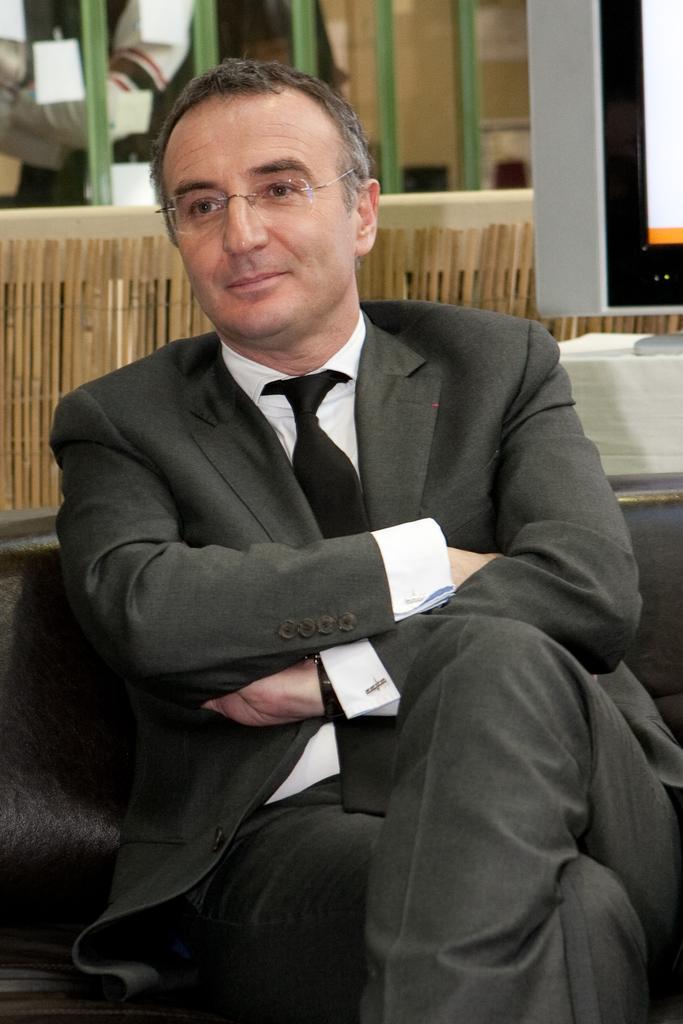Please provide a concise description of this image. In this picture I can see there is a man sitting, he is wearing a blazer, he has spectacles and he is smiling. There is a television in the backdrop and there is a wooden wall. 